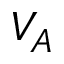<formula> <loc_0><loc_0><loc_500><loc_500>V _ { A }</formula> 